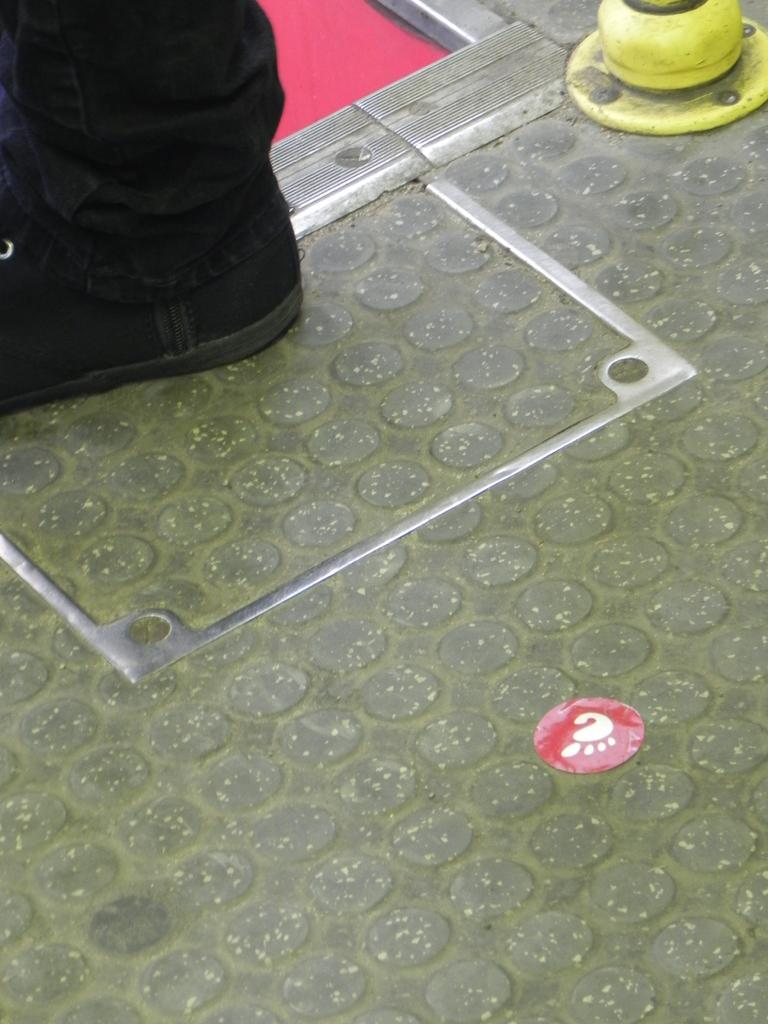What part of a person's body can be seen in the image? There is a person's leg visible in the image. Where is the leg located in the image? The leg is on the floor. What type of object is present in the image besides the leg? There is a sticker in the image. Can you describe the unspecified object in the image? Unfortunately, the facts provided do not give enough information to describe the unspecified object in the image. What type of bean is stored in the jar in the image? There is no jar or bean present in the image. What invention is being demonstrated in the image? There is no invention being demonstrated in the image. 